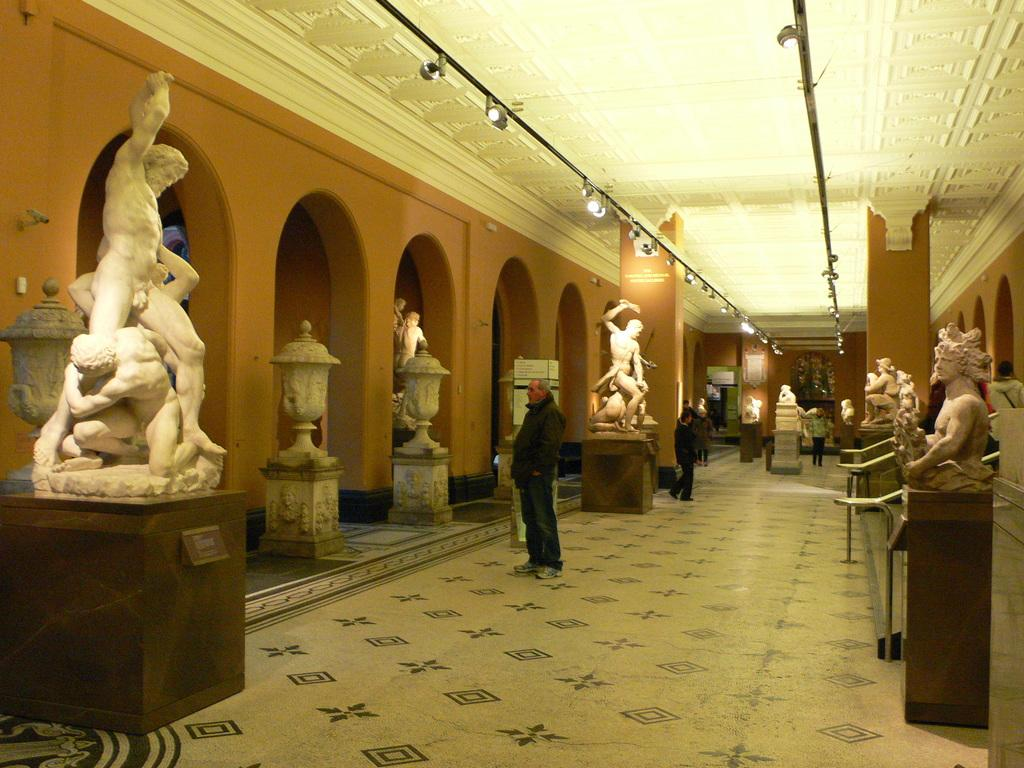What type of objects can be seen in the image? There are statues in the image. What else can be seen in the image besides the statues? There are lights and pillars in the image. Are there any people present in the image? Yes, there are people standing on the floor in the image. What type of glass can be seen in the hands of the people in the image? There is no glass present in the hands of the people in the image. What type of pump is used to power the lights in the image? There is no pump present in the image; the lights are likely powered by electricity. 